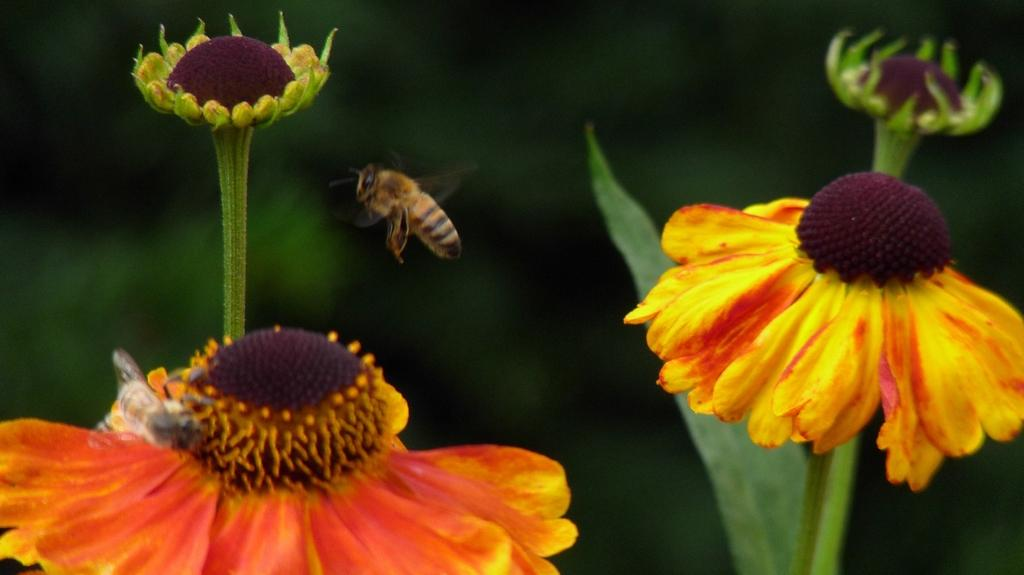What type of living organisms can be seen in the image? There are flowers and a bee in the image. What is the primary subject of the image? The primary subject of the image is the bee. How would you describe the background of the image? The background of the image is blurred. What color are the stockings worn by the bee in the image? There are no stockings present in the image, as bees do not wear clothing. 